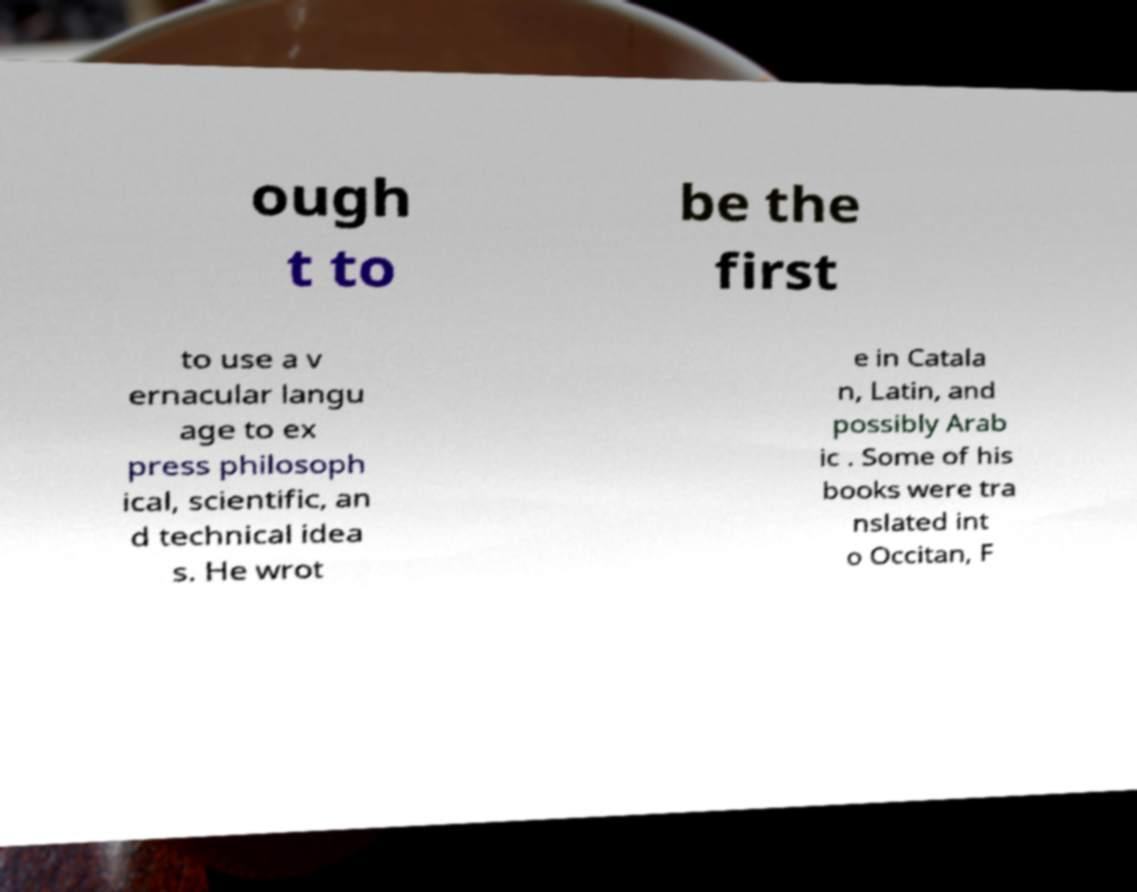Can you read and provide the text displayed in the image?This photo seems to have some interesting text. Can you extract and type it out for me? ough t to be the first to use a v ernacular langu age to ex press philosoph ical, scientific, an d technical idea s. He wrot e in Catala n, Latin, and possibly Arab ic . Some of his books were tra nslated int o Occitan, F 